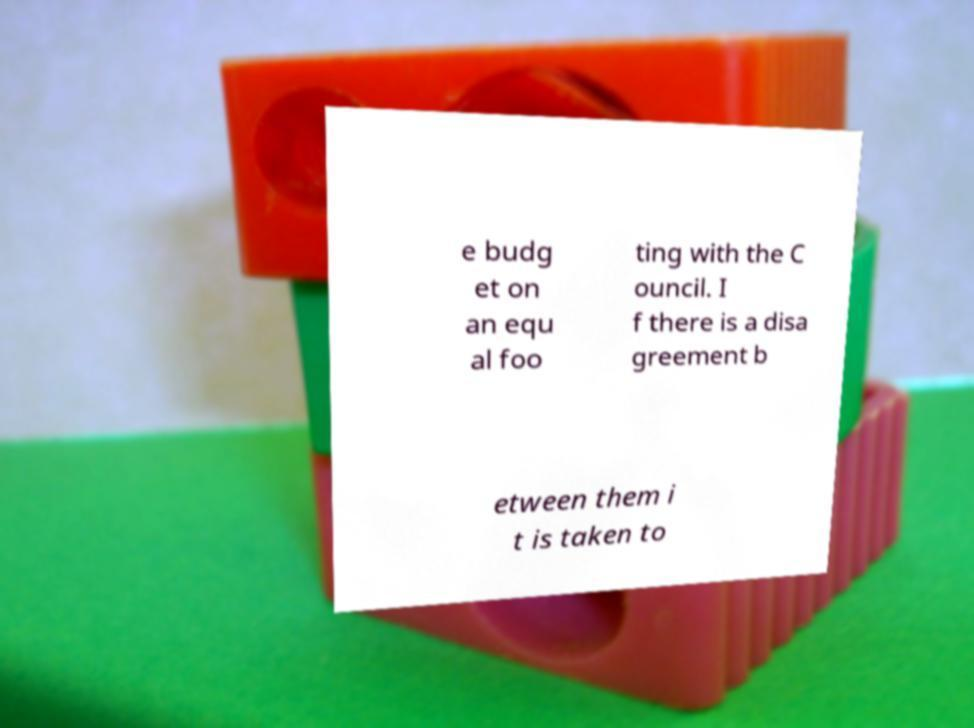I need the written content from this picture converted into text. Can you do that? e budg et on an equ al foo ting with the C ouncil. I f there is a disa greement b etween them i t is taken to 